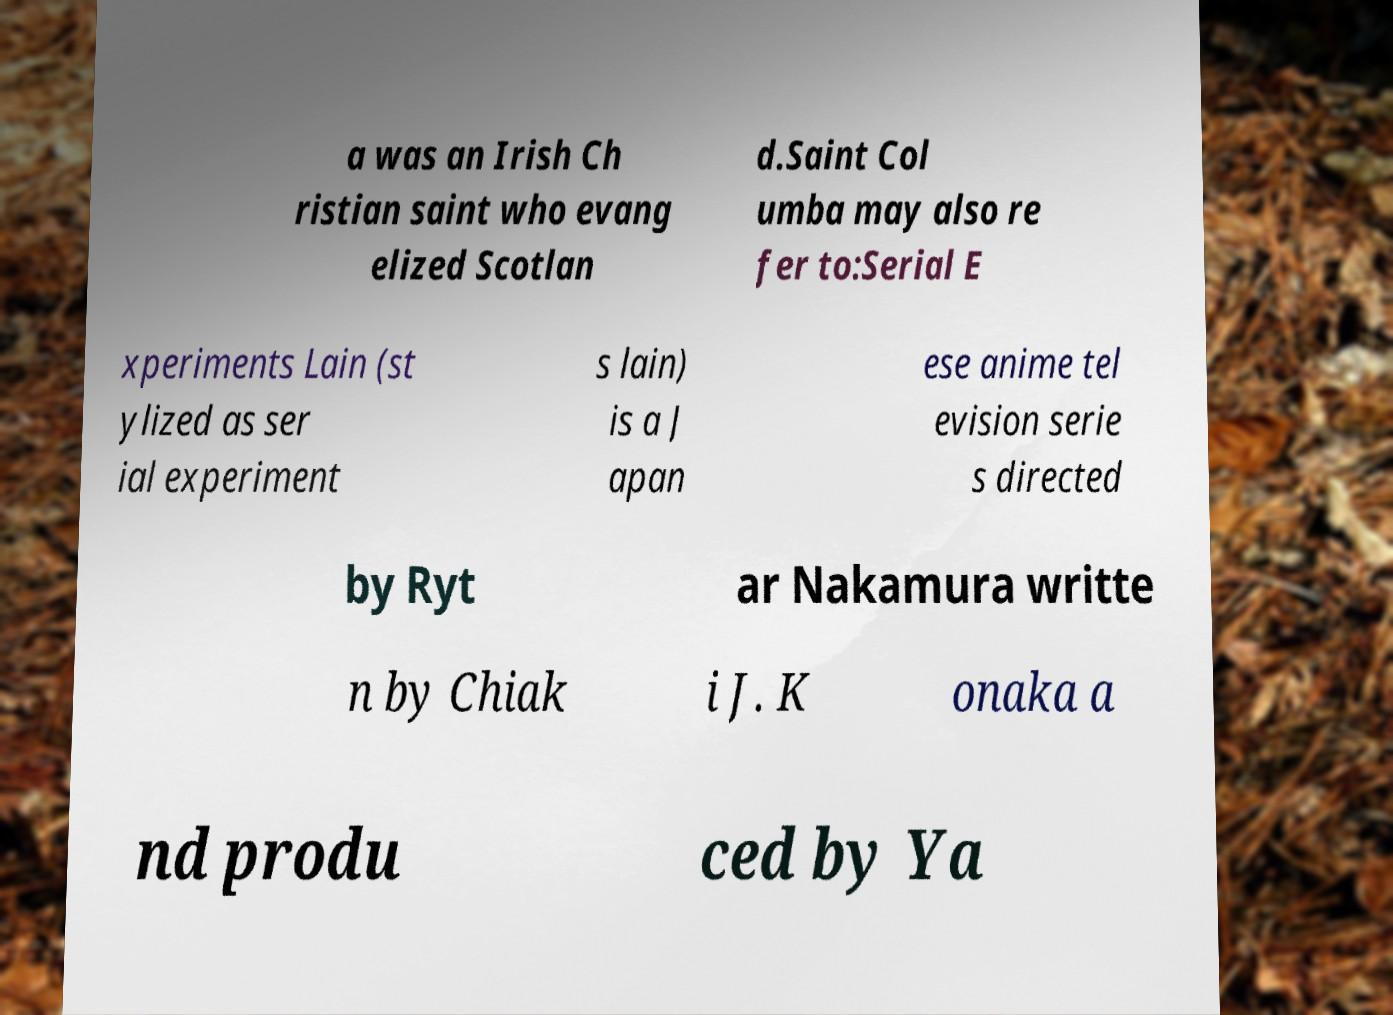I need the written content from this picture converted into text. Can you do that? a was an Irish Ch ristian saint who evang elized Scotlan d.Saint Col umba may also re fer to:Serial E xperiments Lain (st ylized as ser ial experiment s lain) is a J apan ese anime tel evision serie s directed by Ryt ar Nakamura writte n by Chiak i J. K onaka a nd produ ced by Ya 